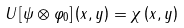<formula> <loc_0><loc_0><loc_500><loc_500>U \left [ \psi \otimes \varphi _ { 0 } \right ] \left ( x , y \right ) = \chi \left ( x , y \right )</formula> 